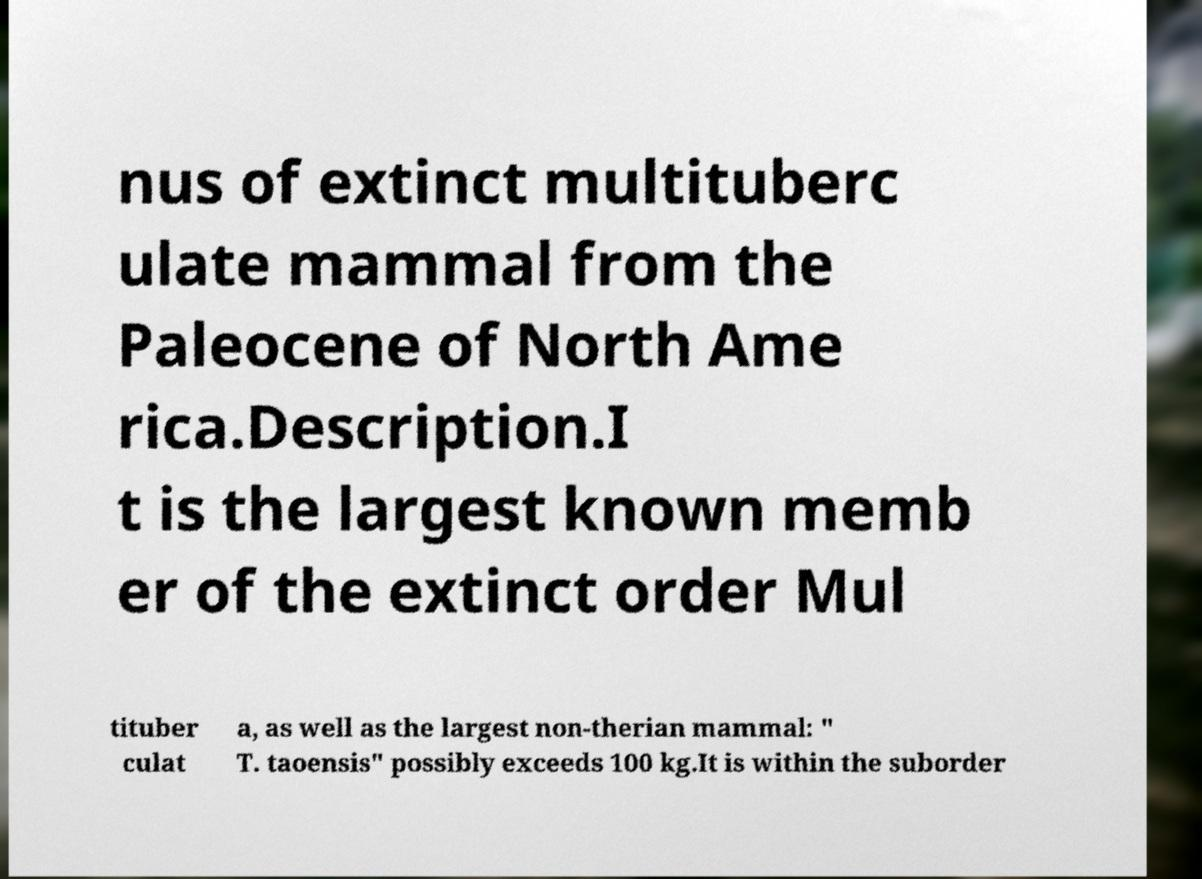Please identify and transcribe the text found in this image. nus of extinct multituberc ulate mammal from the Paleocene of North Ame rica.Description.I t is the largest known memb er of the extinct order Mul tituber culat a, as well as the largest non-therian mammal: " T. taoensis" possibly exceeds 100 kg.It is within the suborder 